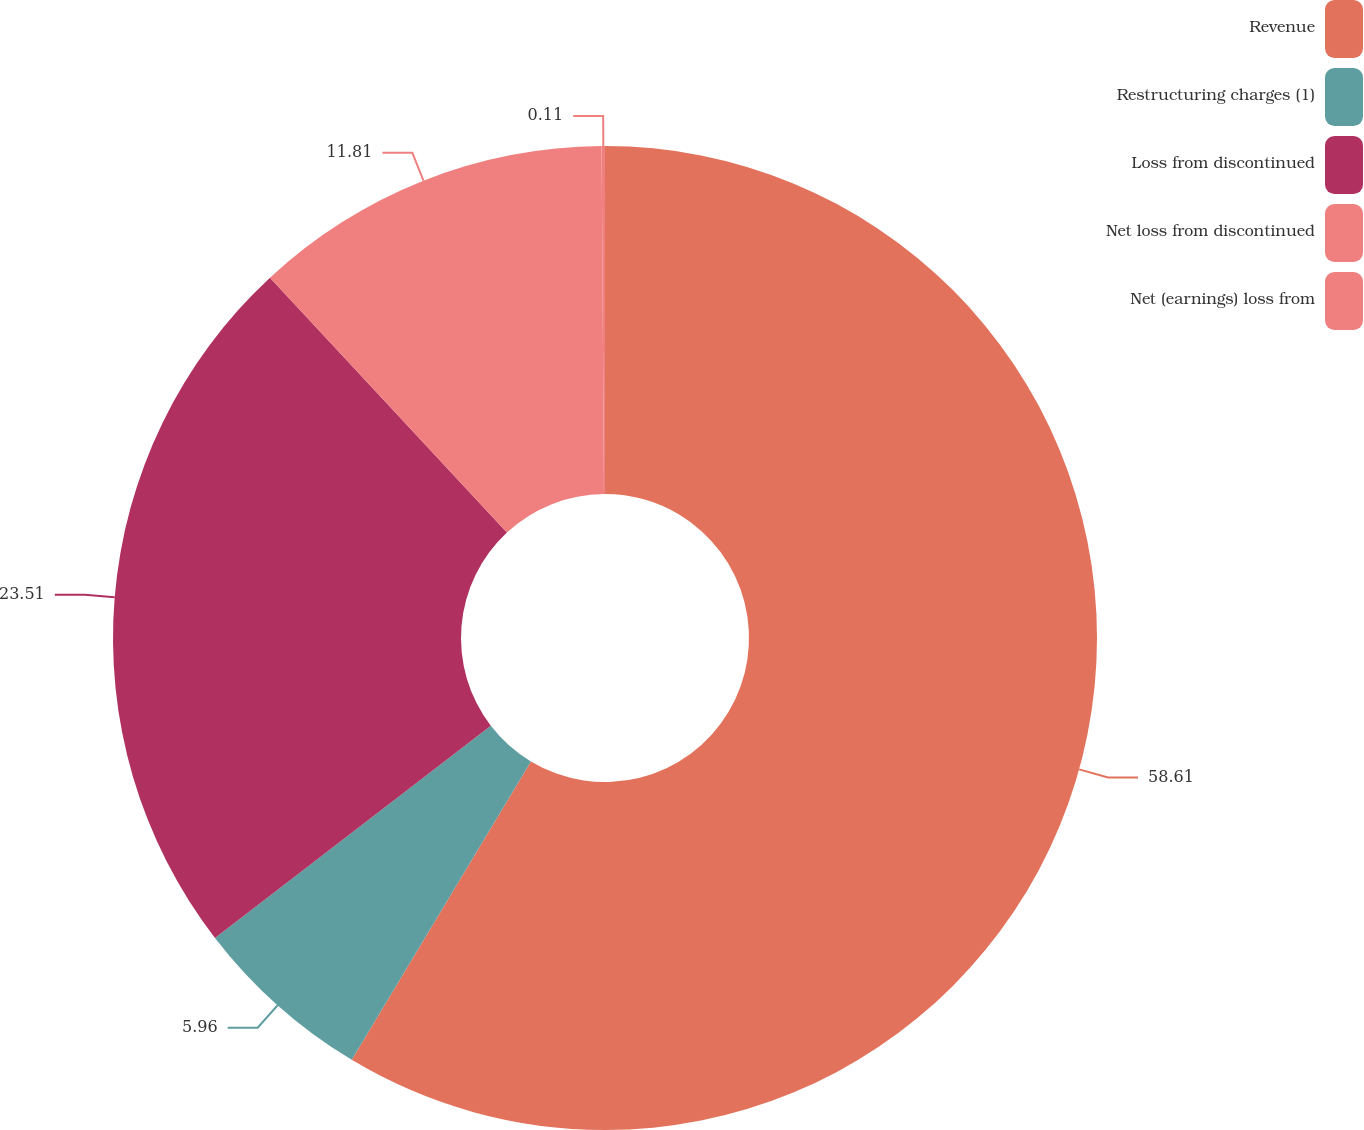Convert chart to OTSL. <chart><loc_0><loc_0><loc_500><loc_500><pie_chart><fcel>Revenue<fcel>Restructuring charges (1)<fcel>Loss from discontinued<fcel>Net loss from discontinued<fcel>Net (earnings) loss from<nl><fcel>58.6%<fcel>5.96%<fcel>23.51%<fcel>11.81%<fcel>0.11%<nl></chart> 